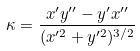<formula> <loc_0><loc_0><loc_500><loc_500>\kappa = \frac { x ^ { \prime } y ^ { \prime \prime } - y ^ { \prime } x ^ { \prime \prime } } { ( x ^ { \prime 2 } + y ^ { \prime 2 } ) ^ { 3 / 2 } }</formula> 